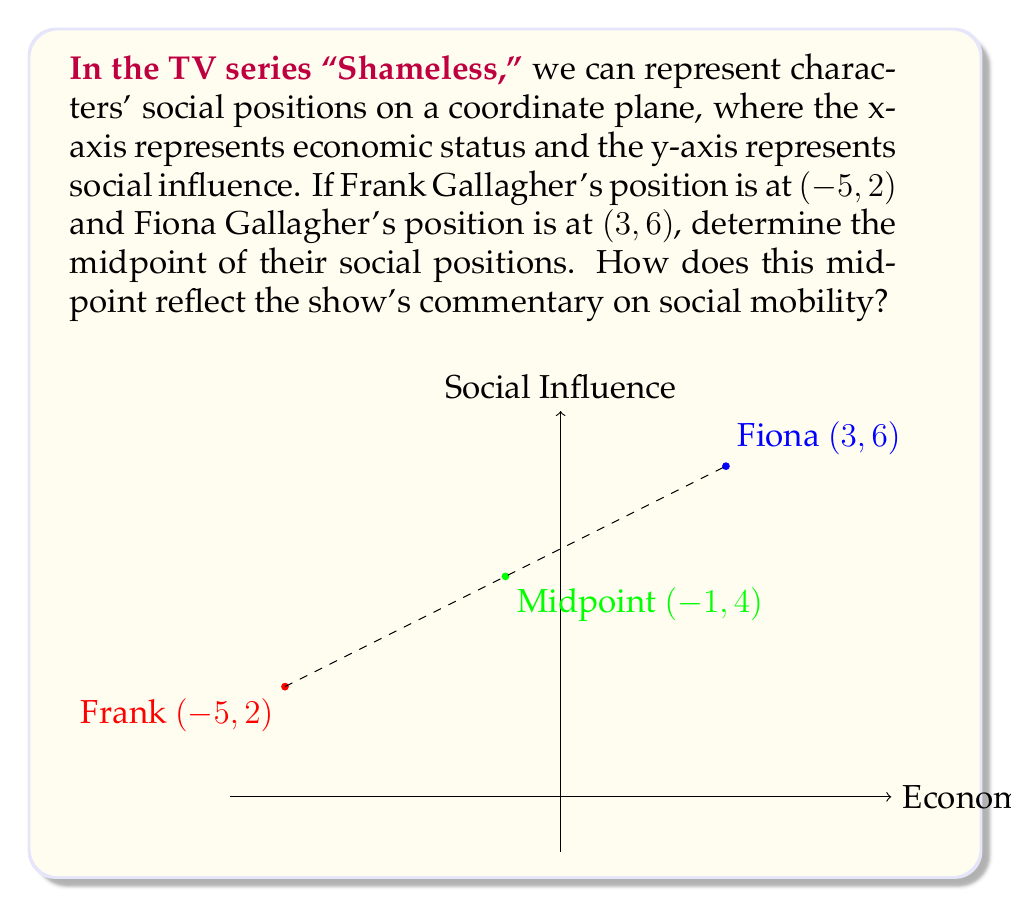Give your solution to this math problem. To solve this problem, we need to use the midpoint formula:

$$ \text{Midpoint} = \left(\frac{x_1 + x_2}{2}, \frac{y_1 + y_2}{2}\right) $$

Where $(x_1, y_1)$ is Frank's position and $(x_2, y_2)$ is Fiona's position.

Step 1: Identify the coordinates
Frank: $(-5, 2)$
Fiona: $(3, 6)$

Step 2: Apply the midpoint formula
$$ \text{Midpoint}_x = \frac{x_1 + x_2}{2} = \frac{-5 + 3}{2} = \frac{-2}{2} = -1 $$
$$ \text{Midpoint}_y = \frac{y_1 + y_2}{2} = \frac{2 + 6}{2} = \frac{8}{2} = 4 $$

Step 3: Combine the results
The midpoint is $(-1, 4)$

This midpoint reflects the show's commentary on social mobility by illustrating:
1. The economic status (-1) is slightly negative, showing the family's overall financial struggles.
2. The social influence (4) is moderately positive, indicating that despite their economic challenges, the Gallaghers have some social capital.
3. The position between Frank and Fiona demonstrates the generational shift and potential for upward mobility within the family.
Answer: $(-1, 4)$ 